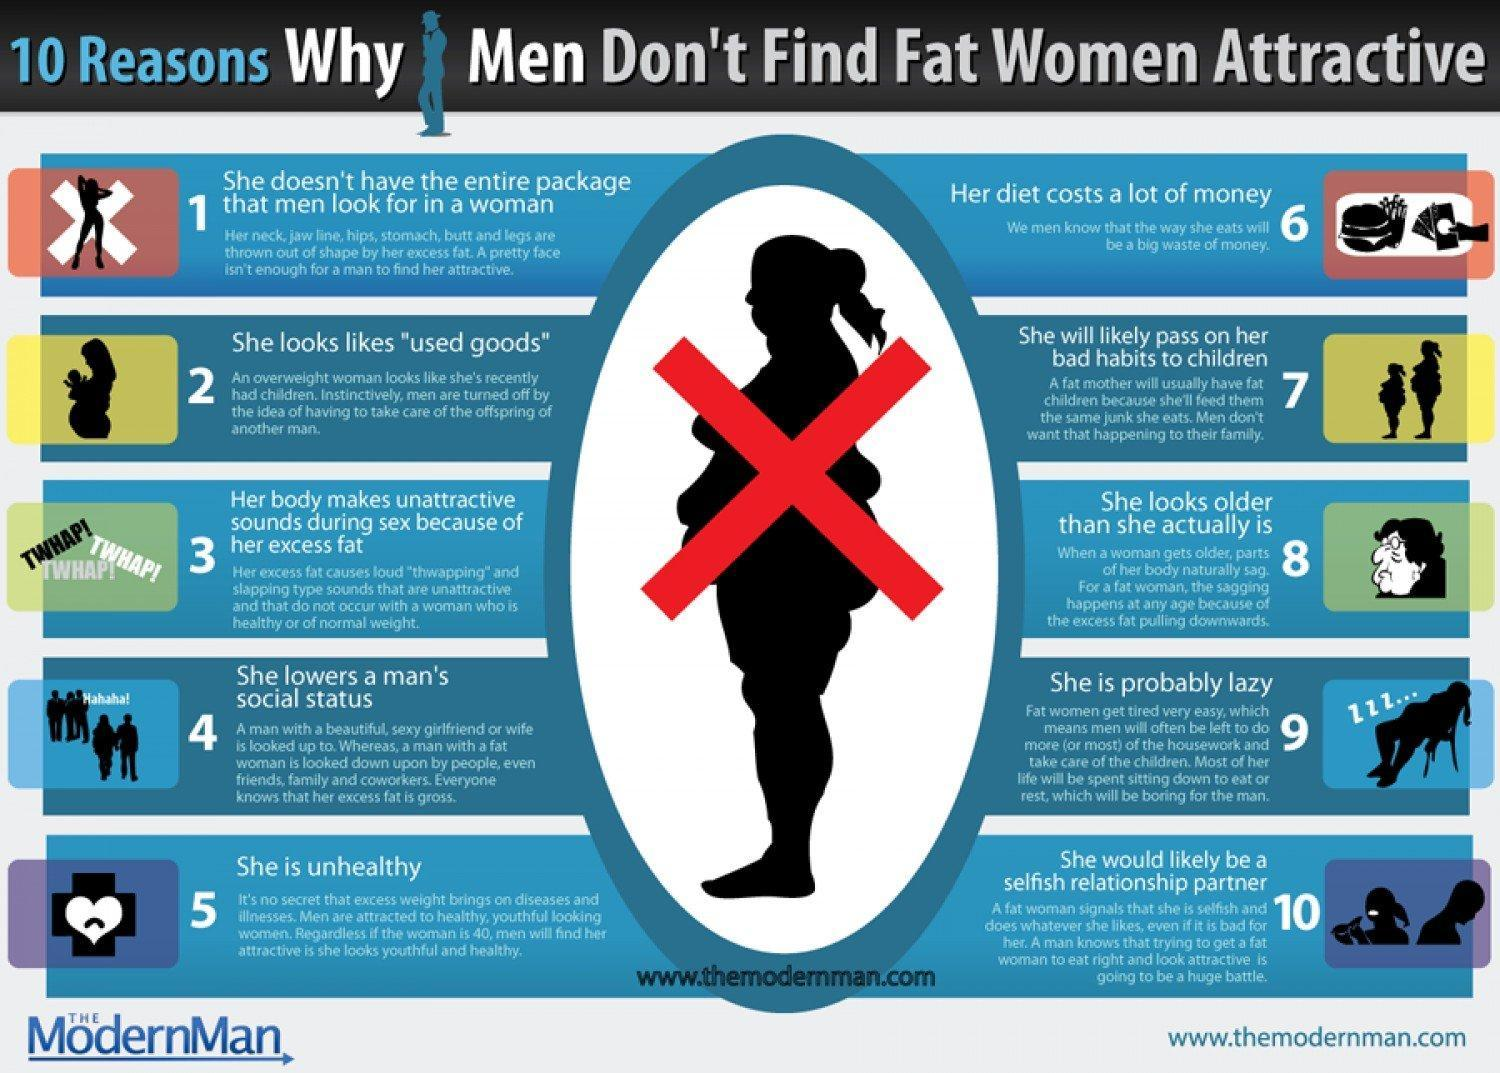who is likely to pass on her bad bahits to children
Answer the question with a short phrase. fat women who looks older that she actually is fat women 